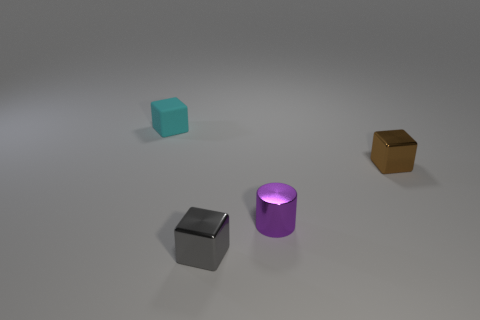Add 4 large green matte objects. How many objects exist? 8 Subtract all cubes. How many objects are left? 1 Subtract all small red balls. Subtract all tiny cyan cubes. How many objects are left? 3 Add 4 tiny cylinders. How many tiny cylinders are left? 5 Add 4 small matte blocks. How many small matte blocks exist? 5 Subtract 0 gray cylinders. How many objects are left? 4 